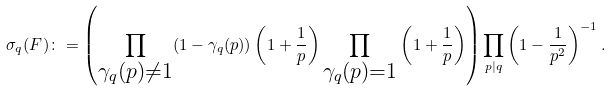<formula> <loc_0><loc_0><loc_500><loc_500>\sigma _ { q } ( F ) \colon = \left ( \prod _ { \substack { \gamma _ { q } ( p ) \neq 1 } } ( 1 - \gamma _ { q } ( p ) ) \left ( 1 + \frac { 1 } { p } \right ) \prod _ { \substack { \gamma _ { q } ( p ) = 1 } } \left ( 1 + \frac { 1 } { p } \right ) \right ) \prod _ { p | q } \left ( 1 - \frac { 1 } { p ^ { 2 } } \right ) ^ { - 1 } .</formula> 